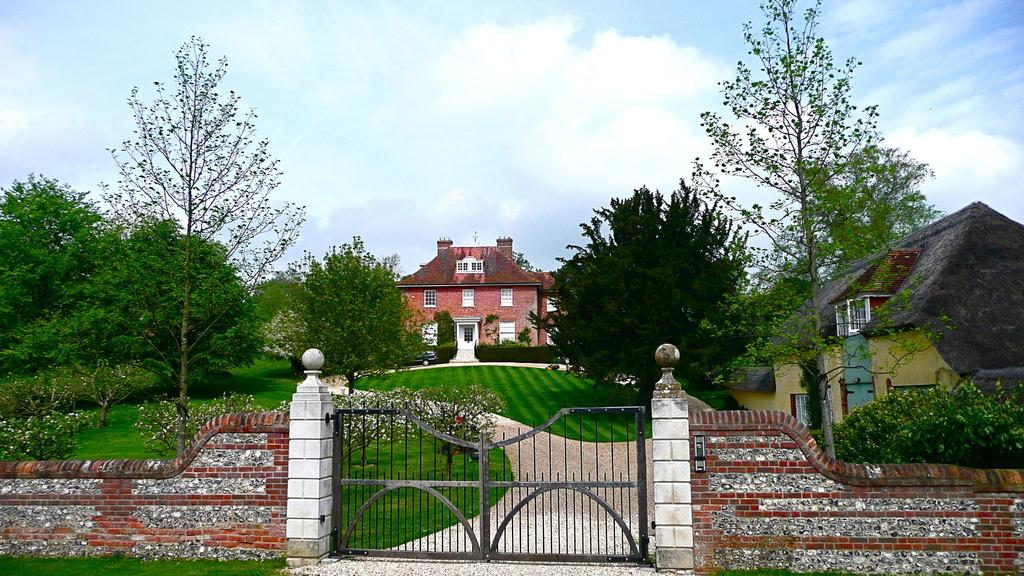What structure is attached to the wall in the image? There is a gate attached to a wall in the image. What type of vegetation can be seen in the image? There are plants and trees in the image. Where are the plants and trees located? The plants and trees are on grassland. What can be seen in the background of the image? There are buildings in the background of the image. What is visible at the top of the image? The sky is visible at the top of the image. What is the condition of the sky in the image? The sky has clouds in the image. Can you tell me which book is being read by the tree in the image? There is no book present in the image, and trees do not read books. Where is the cellar located in the image? There is no cellar present in the image. 